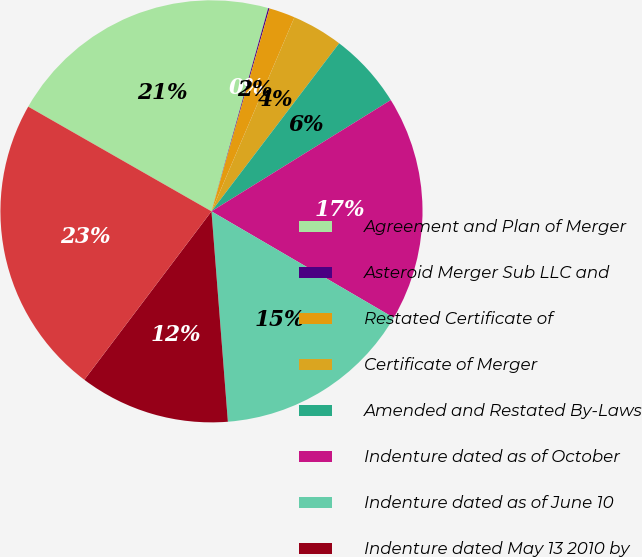<chart> <loc_0><loc_0><loc_500><loc_500><pie_chart><fcel>Agreement and Plan of Merger<fcel>Asteroid Merger Sub LLC and<fcel>Restated Certificate of<fcel>Certificate of Merger<fcel>Amended and Restated By-Laws<fcel>Indenture dated as of October<fcel>Indenture dated as of June 10<fcel>Indenture dated May 13 2010 by<fcel>Supplemental Indenture No 1<nl><fcel>21.07%<fcel>0.1%<fcel>2.0%<fcel>3.91%<fcel>5.82%<fcel>17.25%<fcel>15.35%<fcel>11.53%<fcel>22.97%<nl></chart> 